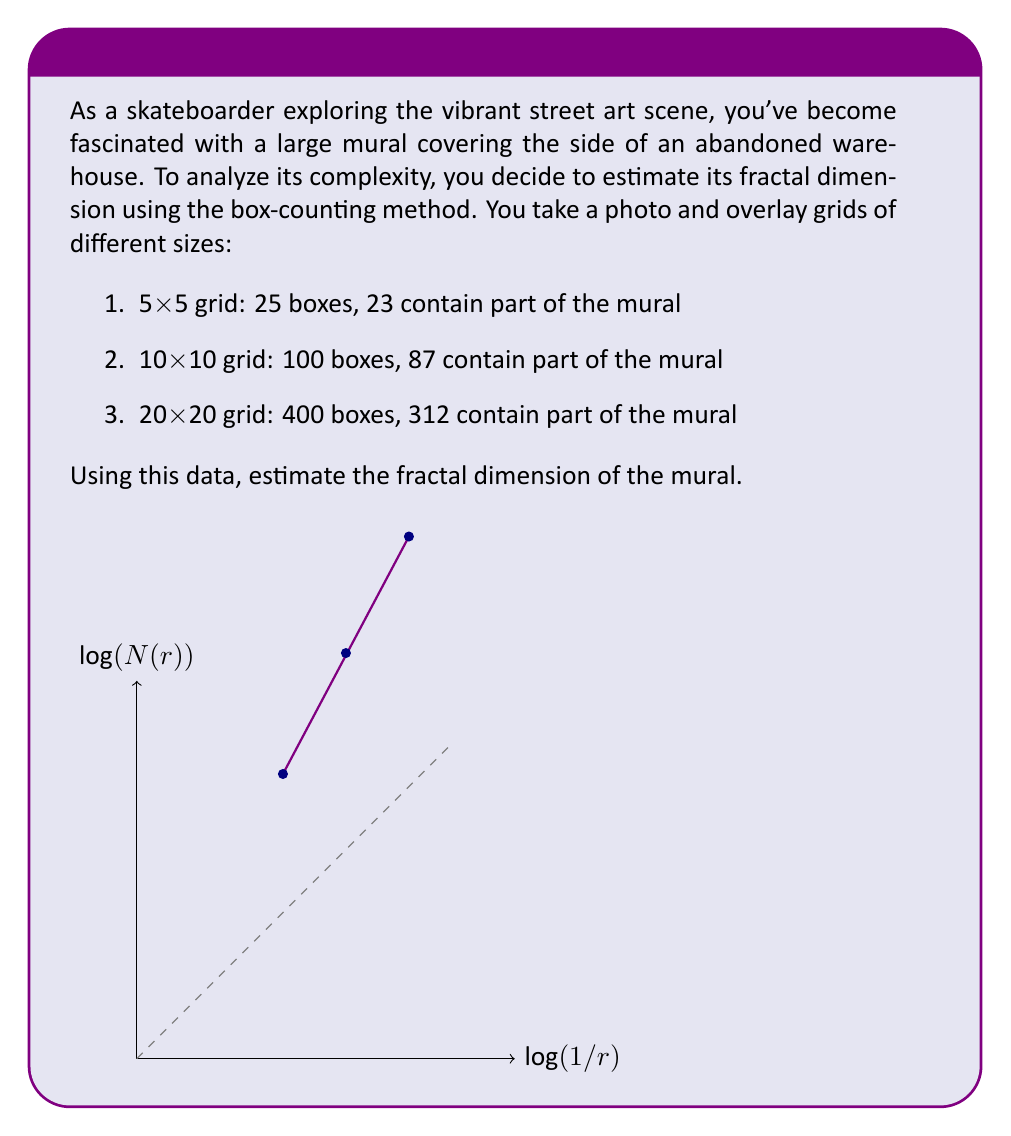Solve this math problem. To estimate the fractal dimension using the box-counting method, we'll use the formula:

$$ D = \lim_{r \to 0} \frac{\log N(r)}{\log(1/r)} $$

Where $D$ is the fractal dimension, $N(r)$ is the number of boxes containing part of the mural, and $r$ is the size of each box relative to the whole image.

Step 1: Prepare the data
Let's organize our data:
- Grid 1: $r_1 = 1/5$, $N(r_1) = 23$
- Grid 2: $r_2 = 1/10$, $N(r_2) = 87$
- Grid 3: $r_3 = 1/20$, $N(r_3) = 312$

Step 2: Plot log-log data
We'll plot $\log(1/r)$ vs $\log(N(r))$:
- Point 1: $(\log(5), \log(23))$
- Point 2: $(\log(10), \log(87))$
- Point 3: $(\log(20), \log(312))$

Step 3: Calculate slope
The slope of this log-log plot is our estimate for $D$. We can use the first and last points for a good approximation:

$$ D \approx \frac{\log(312) - \log(23)}{\log(20) - \log(5)} $$

Step 4: Compute the result
$$ D \approx \frac{\log(312/23)}{\log(20/5)} = \frac{\log(13.5652)}{\log(4)} = \frac{2.6075}{1.3863} \approx 1.8810 $$
Answer: $D \approx 1.88$ 